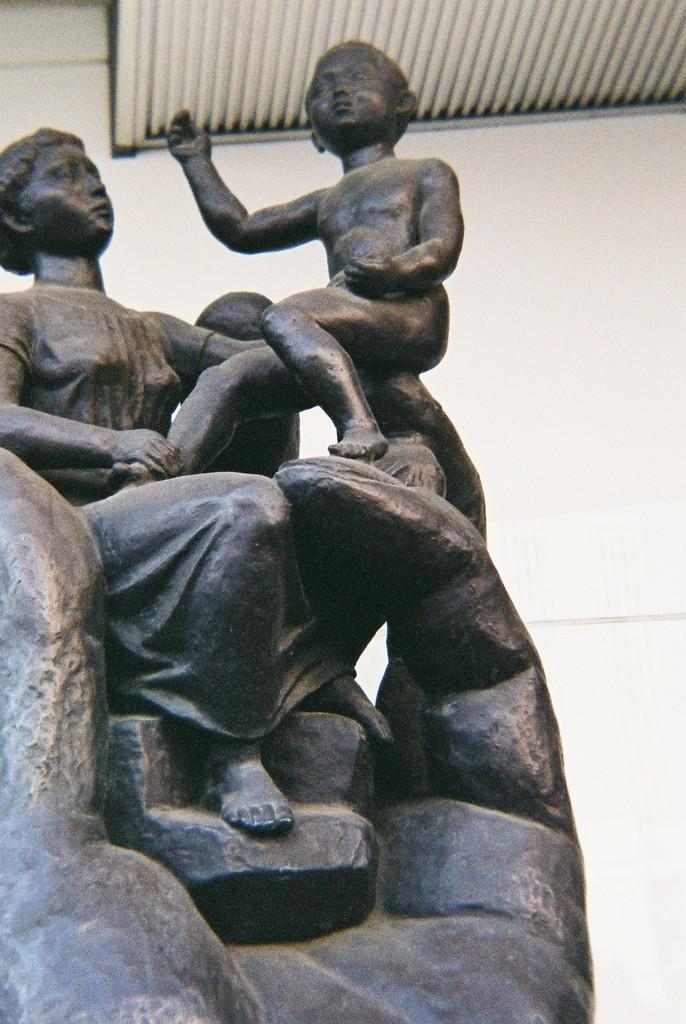What is the main subject of the image? There is a sculpture in the image. What is located at the top of the image? There is a window blind at the top of the image. What can be seen in the background of the image? There is a wall in the background of the image. How many trucks are parked next to the sculpture in the image? There are no trucks present in the image; it only features a sculpture, a window blind, and a wall in the background. 